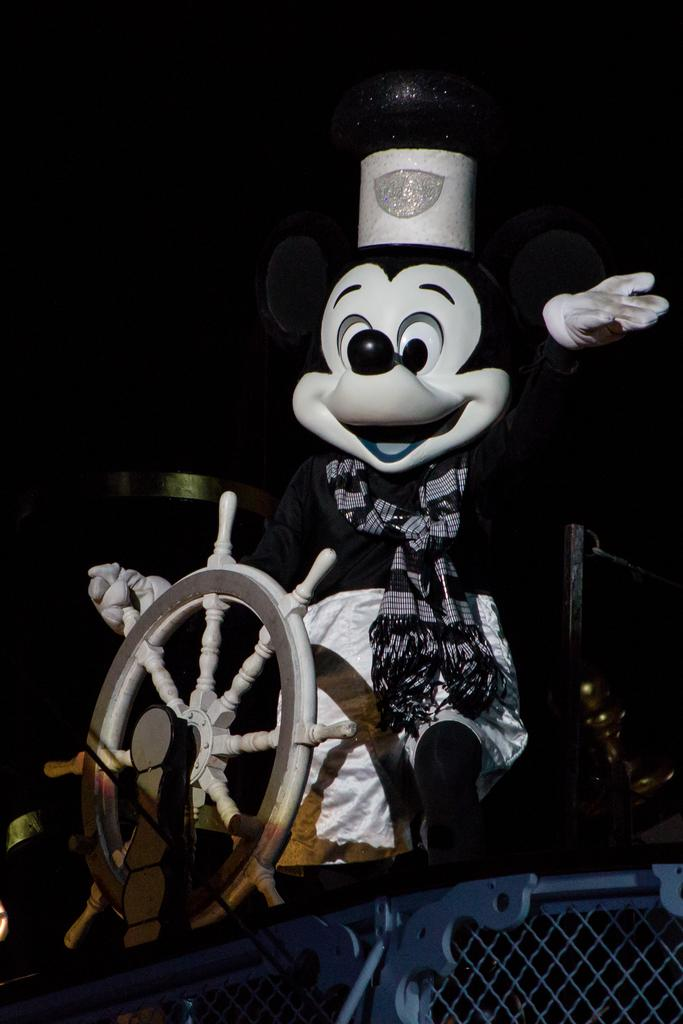What type of content is depicted in the image? There is a cartoon in the image. Are there any specific objects or elements within the cartoon? Yes, there is a wheel in the image. What can be seen at the bottom of the image? There is a fence at the bottom of the image. How is the glue being used in the image? There is no glue present in the image. Can you tell me what type of guitar is being played in the image? There is no guitar present in the image. 